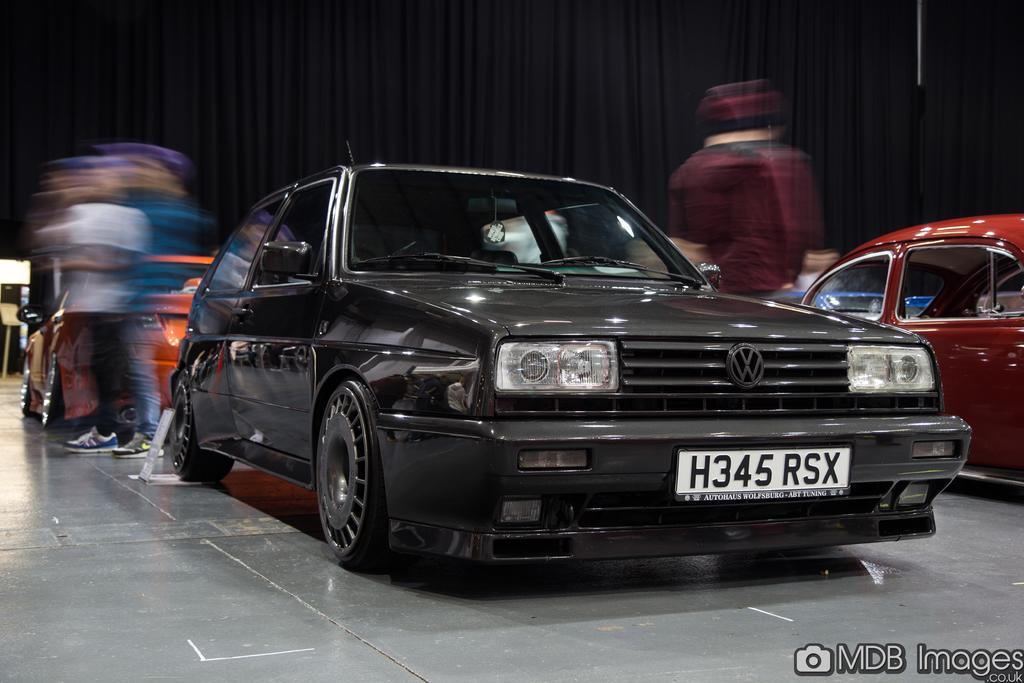Could you give a brief overview of what you see in this image? In this image, we can see two cars, there are some people standing. In the background, we can see a black color curtain, we can see a watermark on the bottom right corner. 